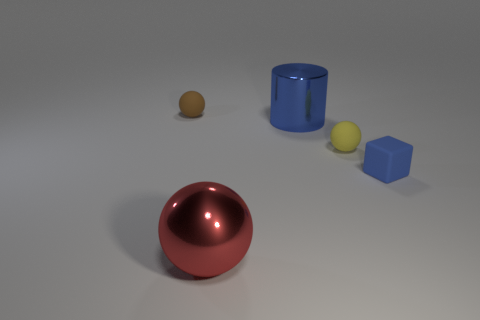The thing that is the same color as the big shiny cylinder is what shape?
Your response must be concise. Cube. Are there more red metallic objects to the right of the cylinder than small gray rubber cylinders?
Your answer should be compact. No. Is the size of the blue matte block the same as the brown thing?
Ensure brevity in your answer.  Yes. What material is the other large object that is the same shape as the yellow object?
Give a very brief answer. Metal. How many red things are either small shiny spheres or spheres?
Keep it short and to the point. 1. There is a large object that is in front of the yellow rubber ball; what material is it?
Your answer should be very brief. Metal. Are there more yellow rubber balls than large metal objects?
Offer a very short reply. No. There is a yellow object that is in front of the brown rubber object; is its shape the same as the brown matte thing?
Offer a very short reply. Yes. How many objects are both behind the large shiny sphere and left of the blue matte object?
Offer a terse response. 3. What number of red objects are the same shape as the tiny brown object?
Provide a short and direct response. 1. 